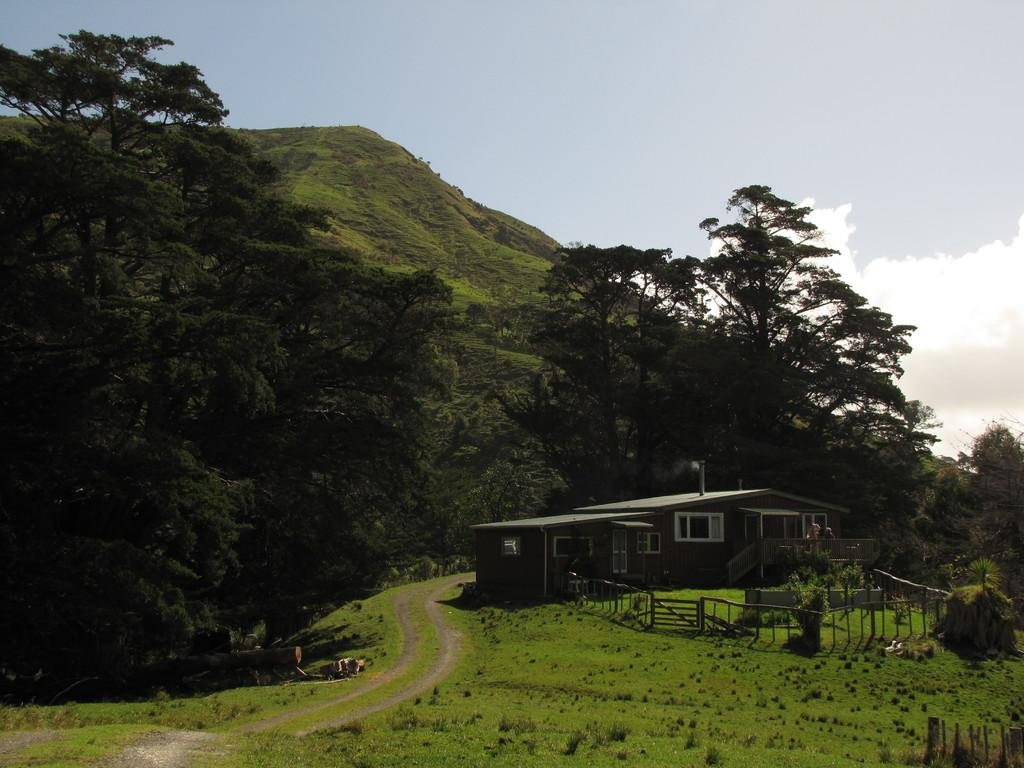What type of vegetation can be seen in the image? There is grass, plants, and trees in the image. What type of structure is present in the image? There is a house with windows in the image. What is the natural feature visible in the background of the image? There is a mountain in the image. What is the man-made feature visible in the image? There is a fence in the image. What else can be seen in the image? There are some objects in the image. What is visible in the sky in the background of the image? The sky is visible in the background of the image. How many birds are sitting on the window in the image? There are no birds present in the image, and there is no window mentioned in the facts. What type of railway can be seen in the image? There is no railway present in the image. 